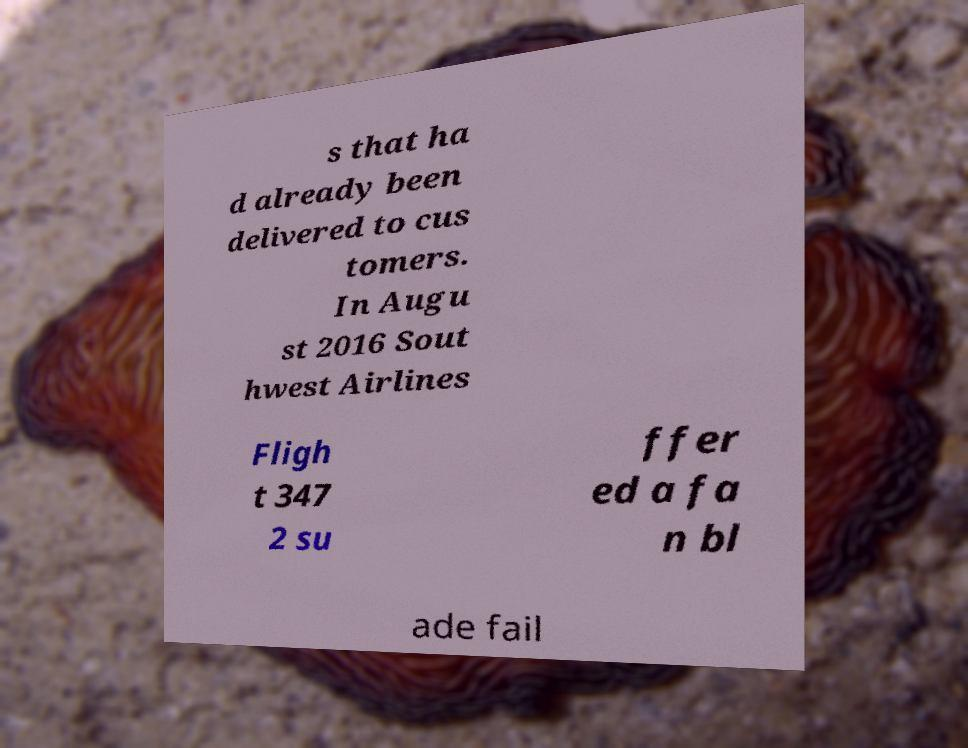What messages or text are displayed in this image? I need them in a readable, typed format. s that ha d already been delivered to cus tomers. In Augu st 2016 Sout hwest Airlines Fligh t 347 2 su ffer ed a fa n bl ade fail 